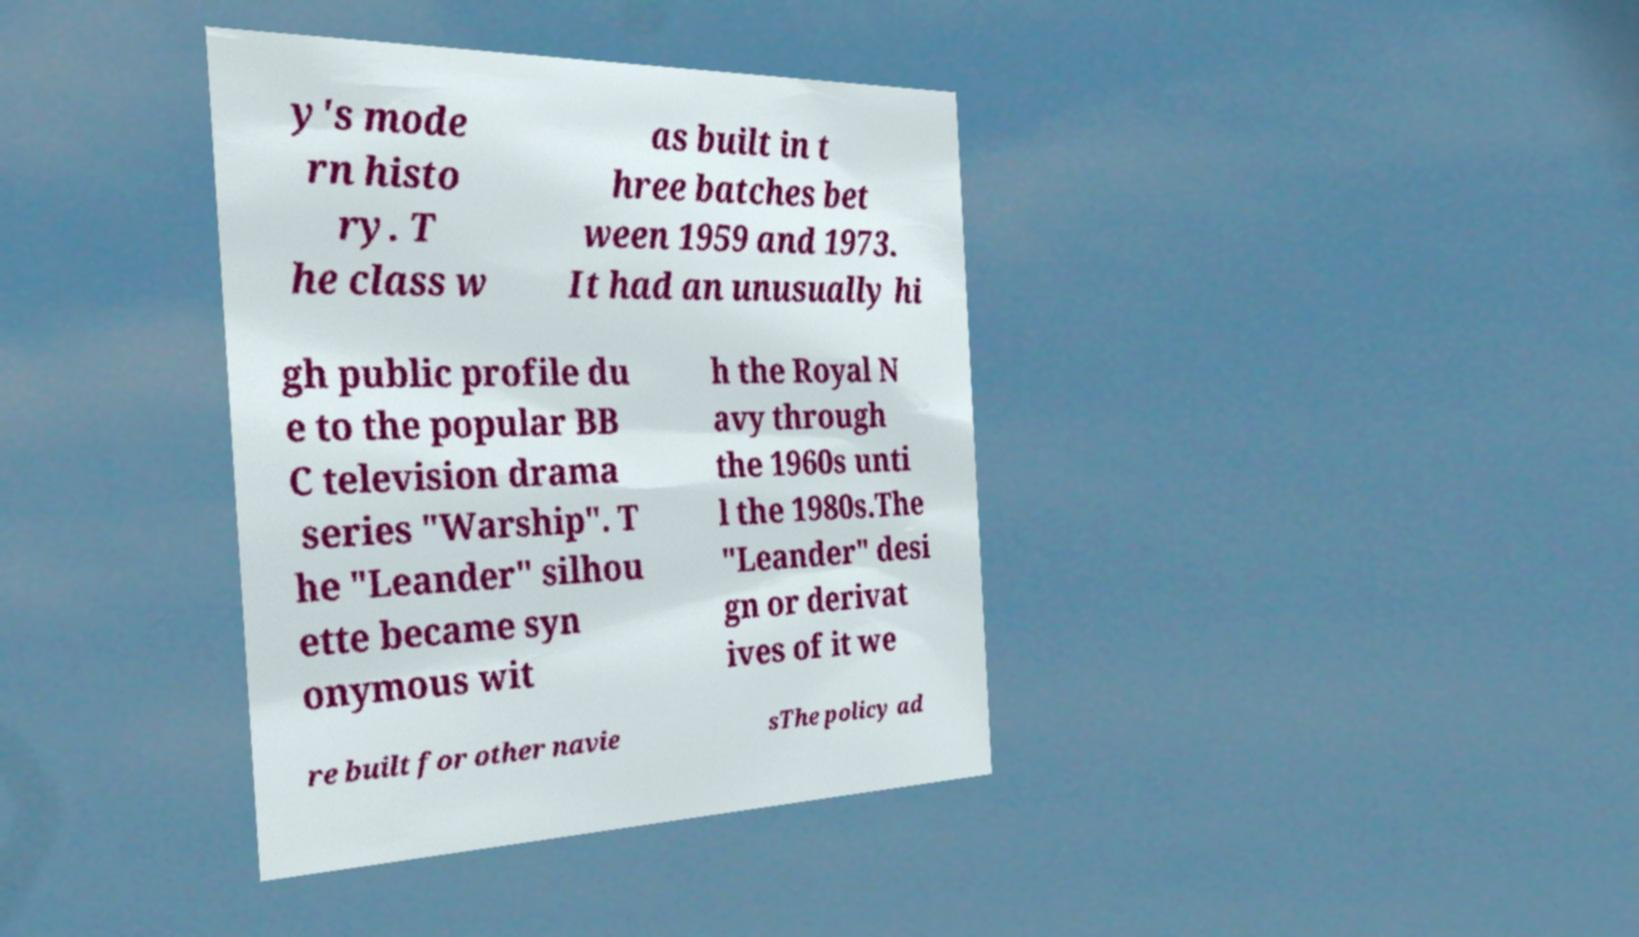Please identify and transcribe the text found in this image. y's mode rn histo ry. T he class w as built in t hree batches bet ween 1959 and 1973. It had an unusually hi gh public profile du e to the popular BB C television drama series "Warship". T he "Leander" silhou ette became syn onymous wit h the Royal N avy through the 1960s unti l the 1980s.The "Leander" desi gn or derivat ives of it we re built for other navie sThe policy ad 